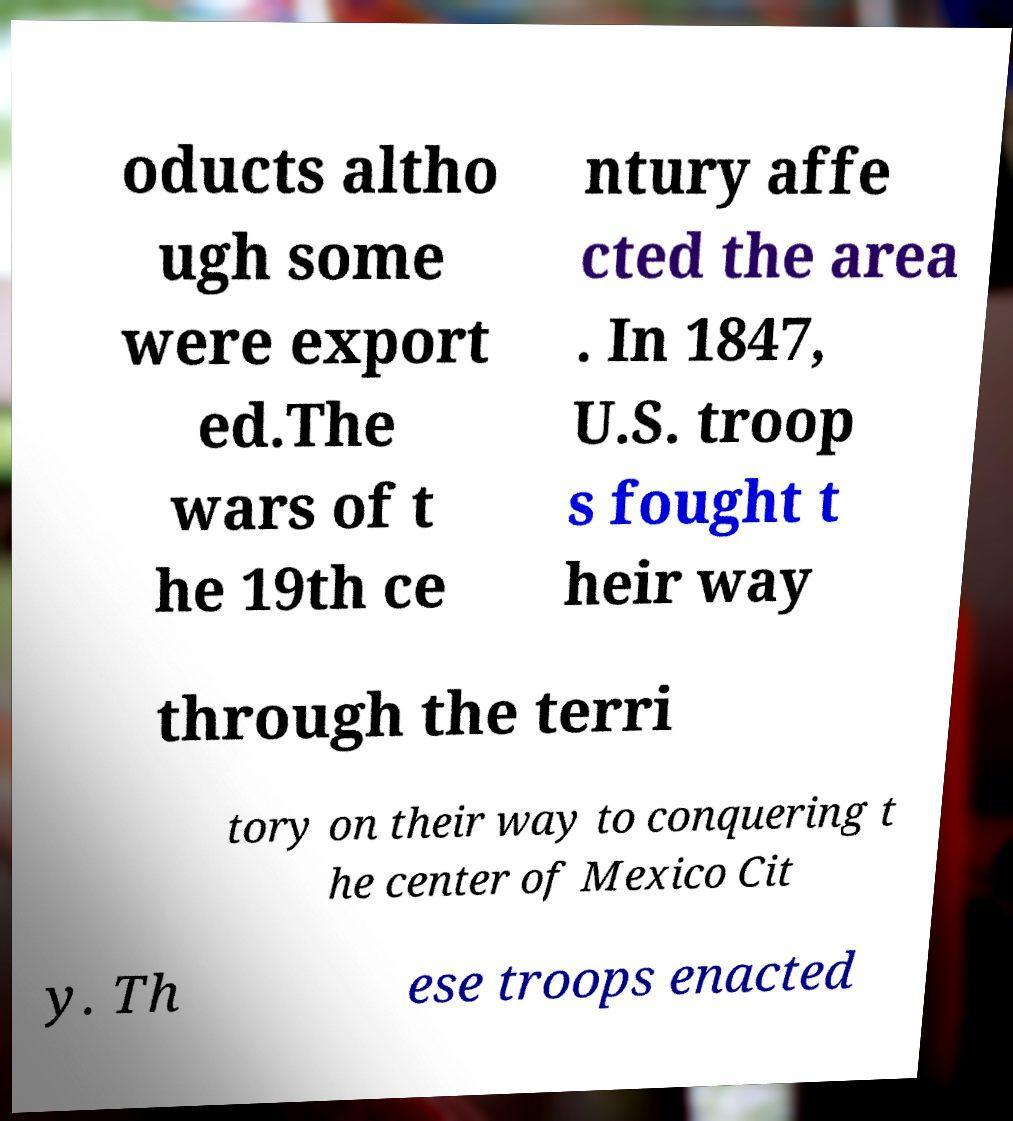Could you assist in decoding the text presented in this image and type it out clearly? oducts altho ugh some were export ed.The wars of t he 19th ce ntury affe cted the area . In 1847, U.S. troop s fought t heir way through the terri tory on their way to conquering t he center of Mexico Cit y. Th ese troops enacted 